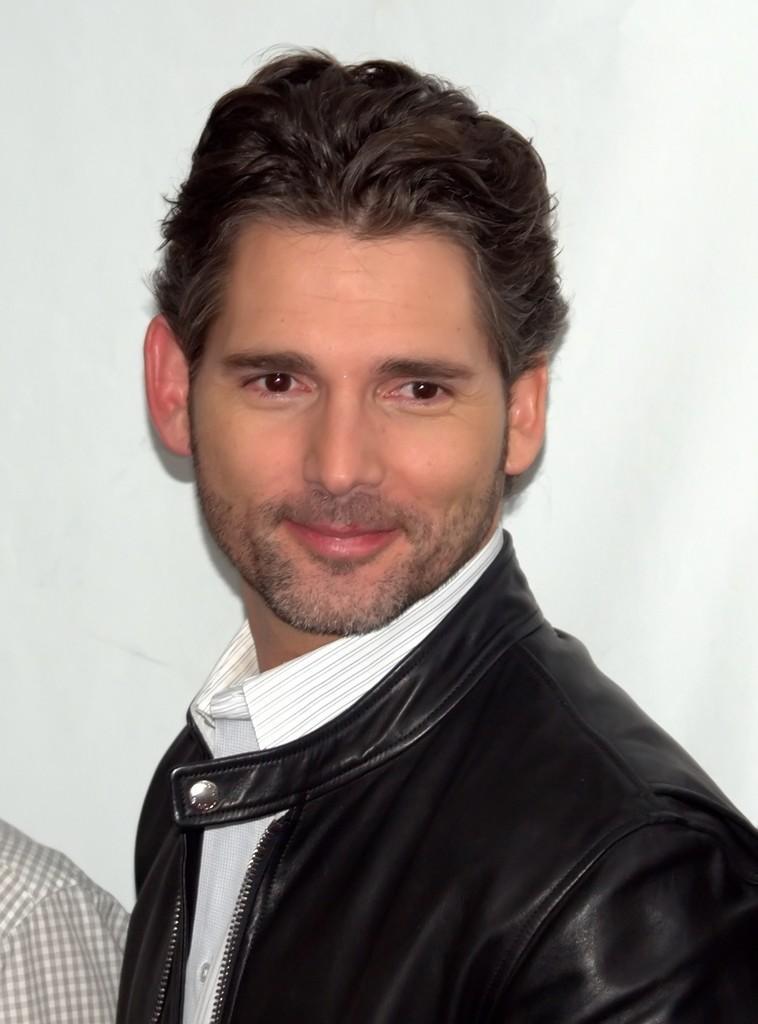In one or two sentences, can you explain what this image depicts? In the foreground of this picture, there is a man in black jacket and having smile on his face. In the background, we can see a hand of a person and a wall. 